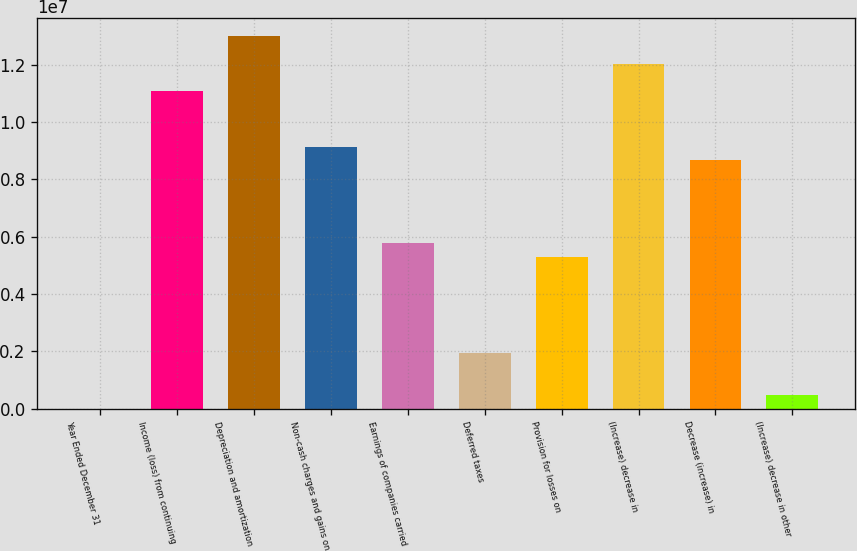Convert chart. <chart><loc_0><loc_0><loc_500><loc_500><bar_chart><fcel>Year Ended December 31<fcel>Income (loss) from continuing<fcel>Depreciation and amortization<fcel>Non-cash charges and gains on<fcel>Earnings of companies carried<fcel>Deferred taxes<fcel>Provision for losses on<fcel>(Increase) decrease in<fcel>Decrease (increase) in<fcel>(Increase) decrease in other<nl><fcel>2001<fcel>1.1072e+07<fcel>1.29972e+07<fcel>9.14675e+06<fcel>5.77763e+06<fcel>1.92721e+06<fcel>5.29633e+06<fcel>1.20346e+07<fcel>8.66545e+06<fcel>483304<nl></chart> 